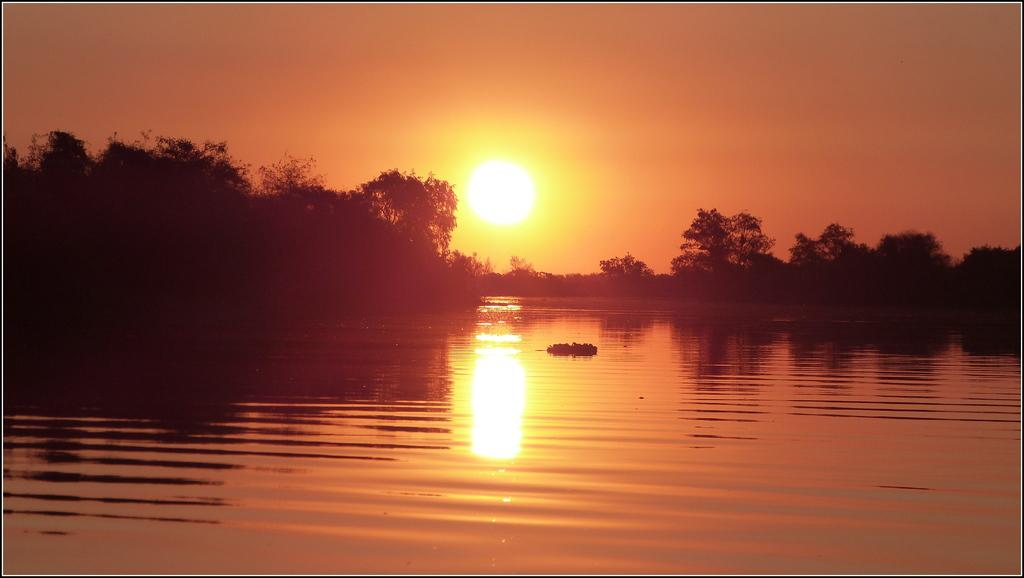What type of setting is depicted in the image? The image is an outside view. What can be seen at the bottom of the image? There is water visible at the bottom of the image. What is visible in the background of the image? There are many trees in the background of the image. What is visible at the top of the image? The sky is visible at the top of the image. Can the sun be seen in the image? Yes, the sun is observable in the sky. What type of string is being used by the secretary in the image? There is no secretary or string present in the image. What type of doctor can be seen treating patients in the image? There is no doctor or patients present in the image. 